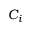<formula> <loc_0><loc_0><loc_500><loc_500>C _ { i }</formula> 